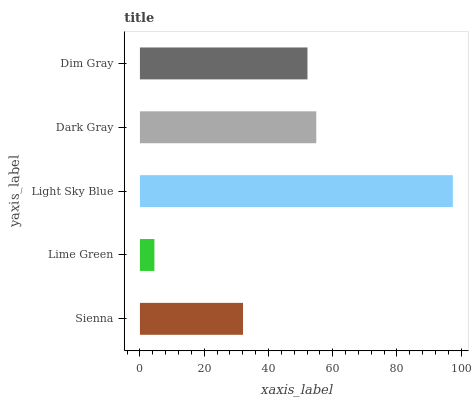Is Lime Green the minimum?
Answer yes or no. Yes. Is Light Sky Blue the maximum?
Answer yes or no. Yes. Is Light Sky Blue the minimum?
Answer yes or no. No. Is Lime Green the maximum?
Answer yes or no. No. Is Light Sky Blue greater than Lime Green?
Answer yes or no. Yes. Is Lime Green less than Light Sky Blue?
Answer yes or no. Yes. Is Lime Green greater than Light Sky Blue?
Answer yes or no. No. Is Light Sky Blue less than Lime Green?
Answer yes or no. No. Is Dim Gray the high median?
Answer yes or no. Yes. Is Dim Gray the low median?
Answer yes or no. Yes. Is Dark Gray the high median?
Answer yes or no. No. Is Dark Gray the low median?
Answer yes or no. No. 